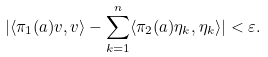<formula> <loc_0><loc_0><loc_500><loc_500>| \langle \pi _ { 1 } ( a ) v , v \rangle - \sum _ { k = 1 } ^ { n } \langle \pi _ { 2 } ( a ) \eta _ { k } , \eta _ { k } \rangle | < \varepsilon .</formula> 